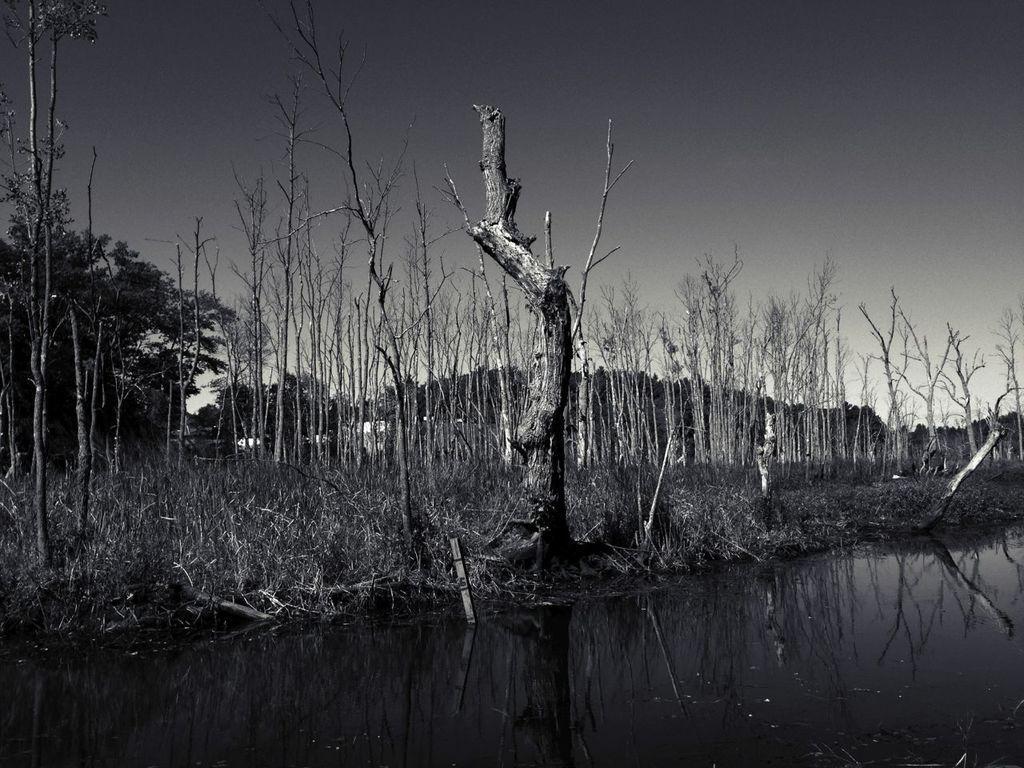Describe this image in one or two sentences. We can see water,grass and tree trunk. Background we can see trees and sky. 